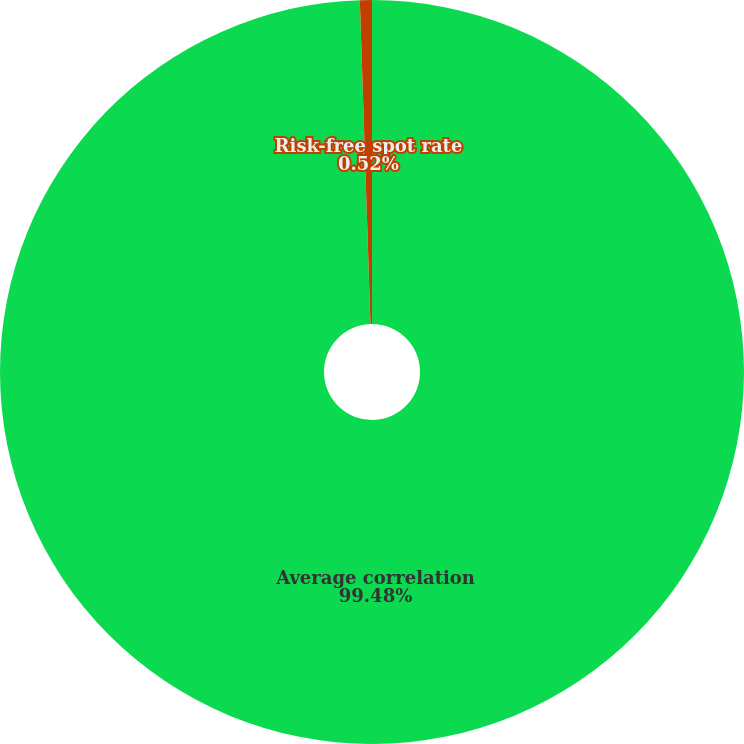Convert chart. <chart><loc_0><loc_0><loc_500><loc_500><pie_chart><fcel>Average correlation<fcel>Risk-free spot rate<nl><fcel>99.48%<fcel>0.52%<nl></chart> 